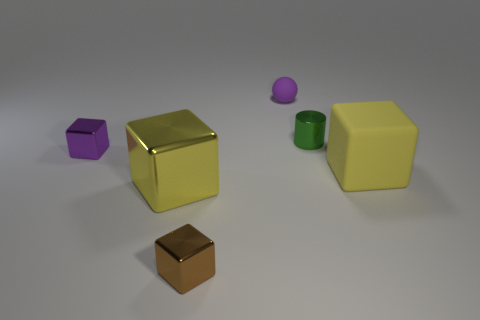There is a cube that is both on the left side of the small cylinder and to the right of the big yellow shiny object; what material is it?
Give a very brief answer. Metal. What shape is the other purple thing that is the same size as the purple shiny object?
Your response must be concise. Sphere. What color is the small metal thing in front of the shiny object that is left of the yellow object that is on the left side of the brown metal cube?
Ensure brevity in your answer.  Brown. How many objects are things that are on the left side of the yellow metallic block or tiny green cubes?
Provide a short and direct response. 1. What is the material of the purple object that is the same size as the purple cube?
Make the answer very short. Rubber. The yellow cube on the right side of the small thing that is in front of the purple thing to the left of the tiny rubber object is made of what material?
Your response must be concise. Rubber. The big matte block is what color?
Your answer should be very brief. Yellow. How many small objects are either cylinders or purple objects?
Make the answer very short. 3. There is a large object that is the same color as the large matte block; what is it made of?
Provide a succinct answer. Metal. Do the tiny block on the right side of the purple shiny cube and the tiny green object that is behind the purple metallic block have the same material?
Provide a short and direct response. Yes. 